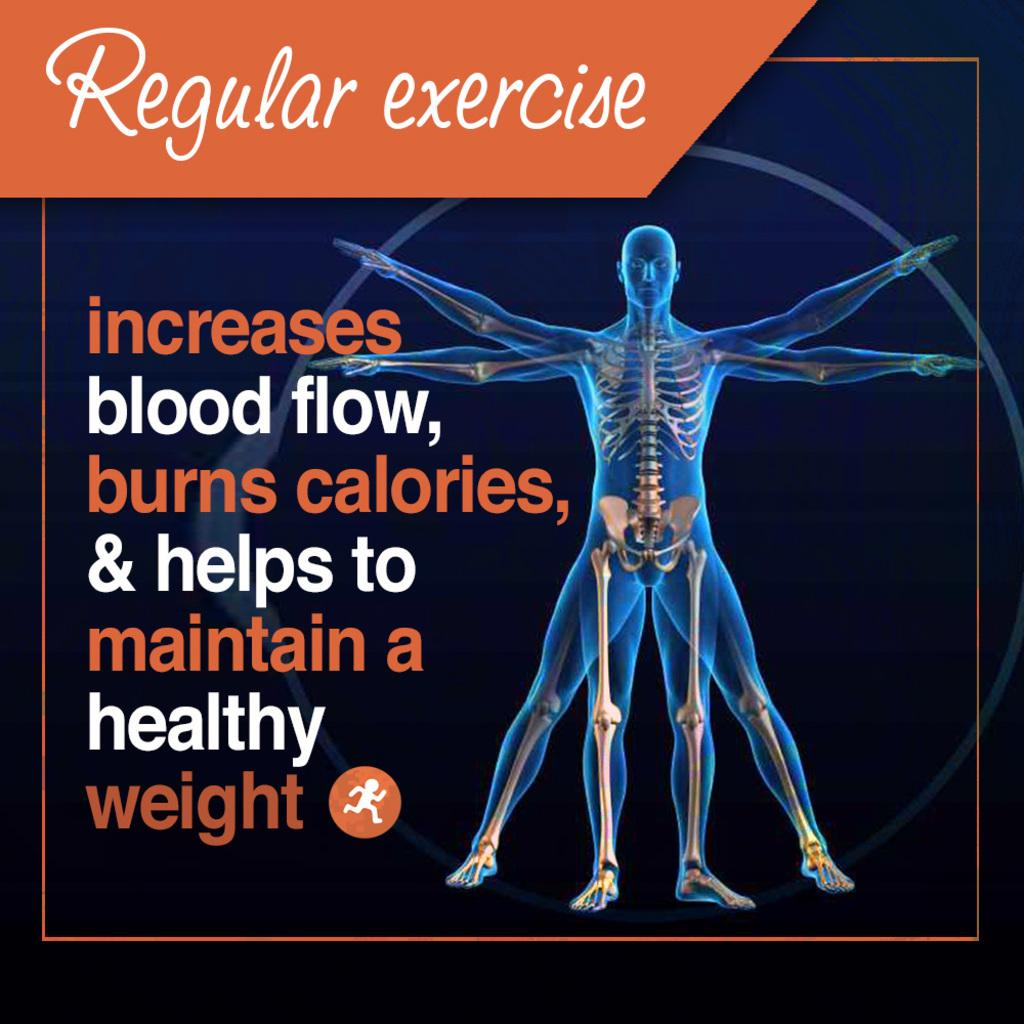<image>
Create a compact narrative representing the image presented. A poster promoting regular exercise notes the benefits of exercise. 